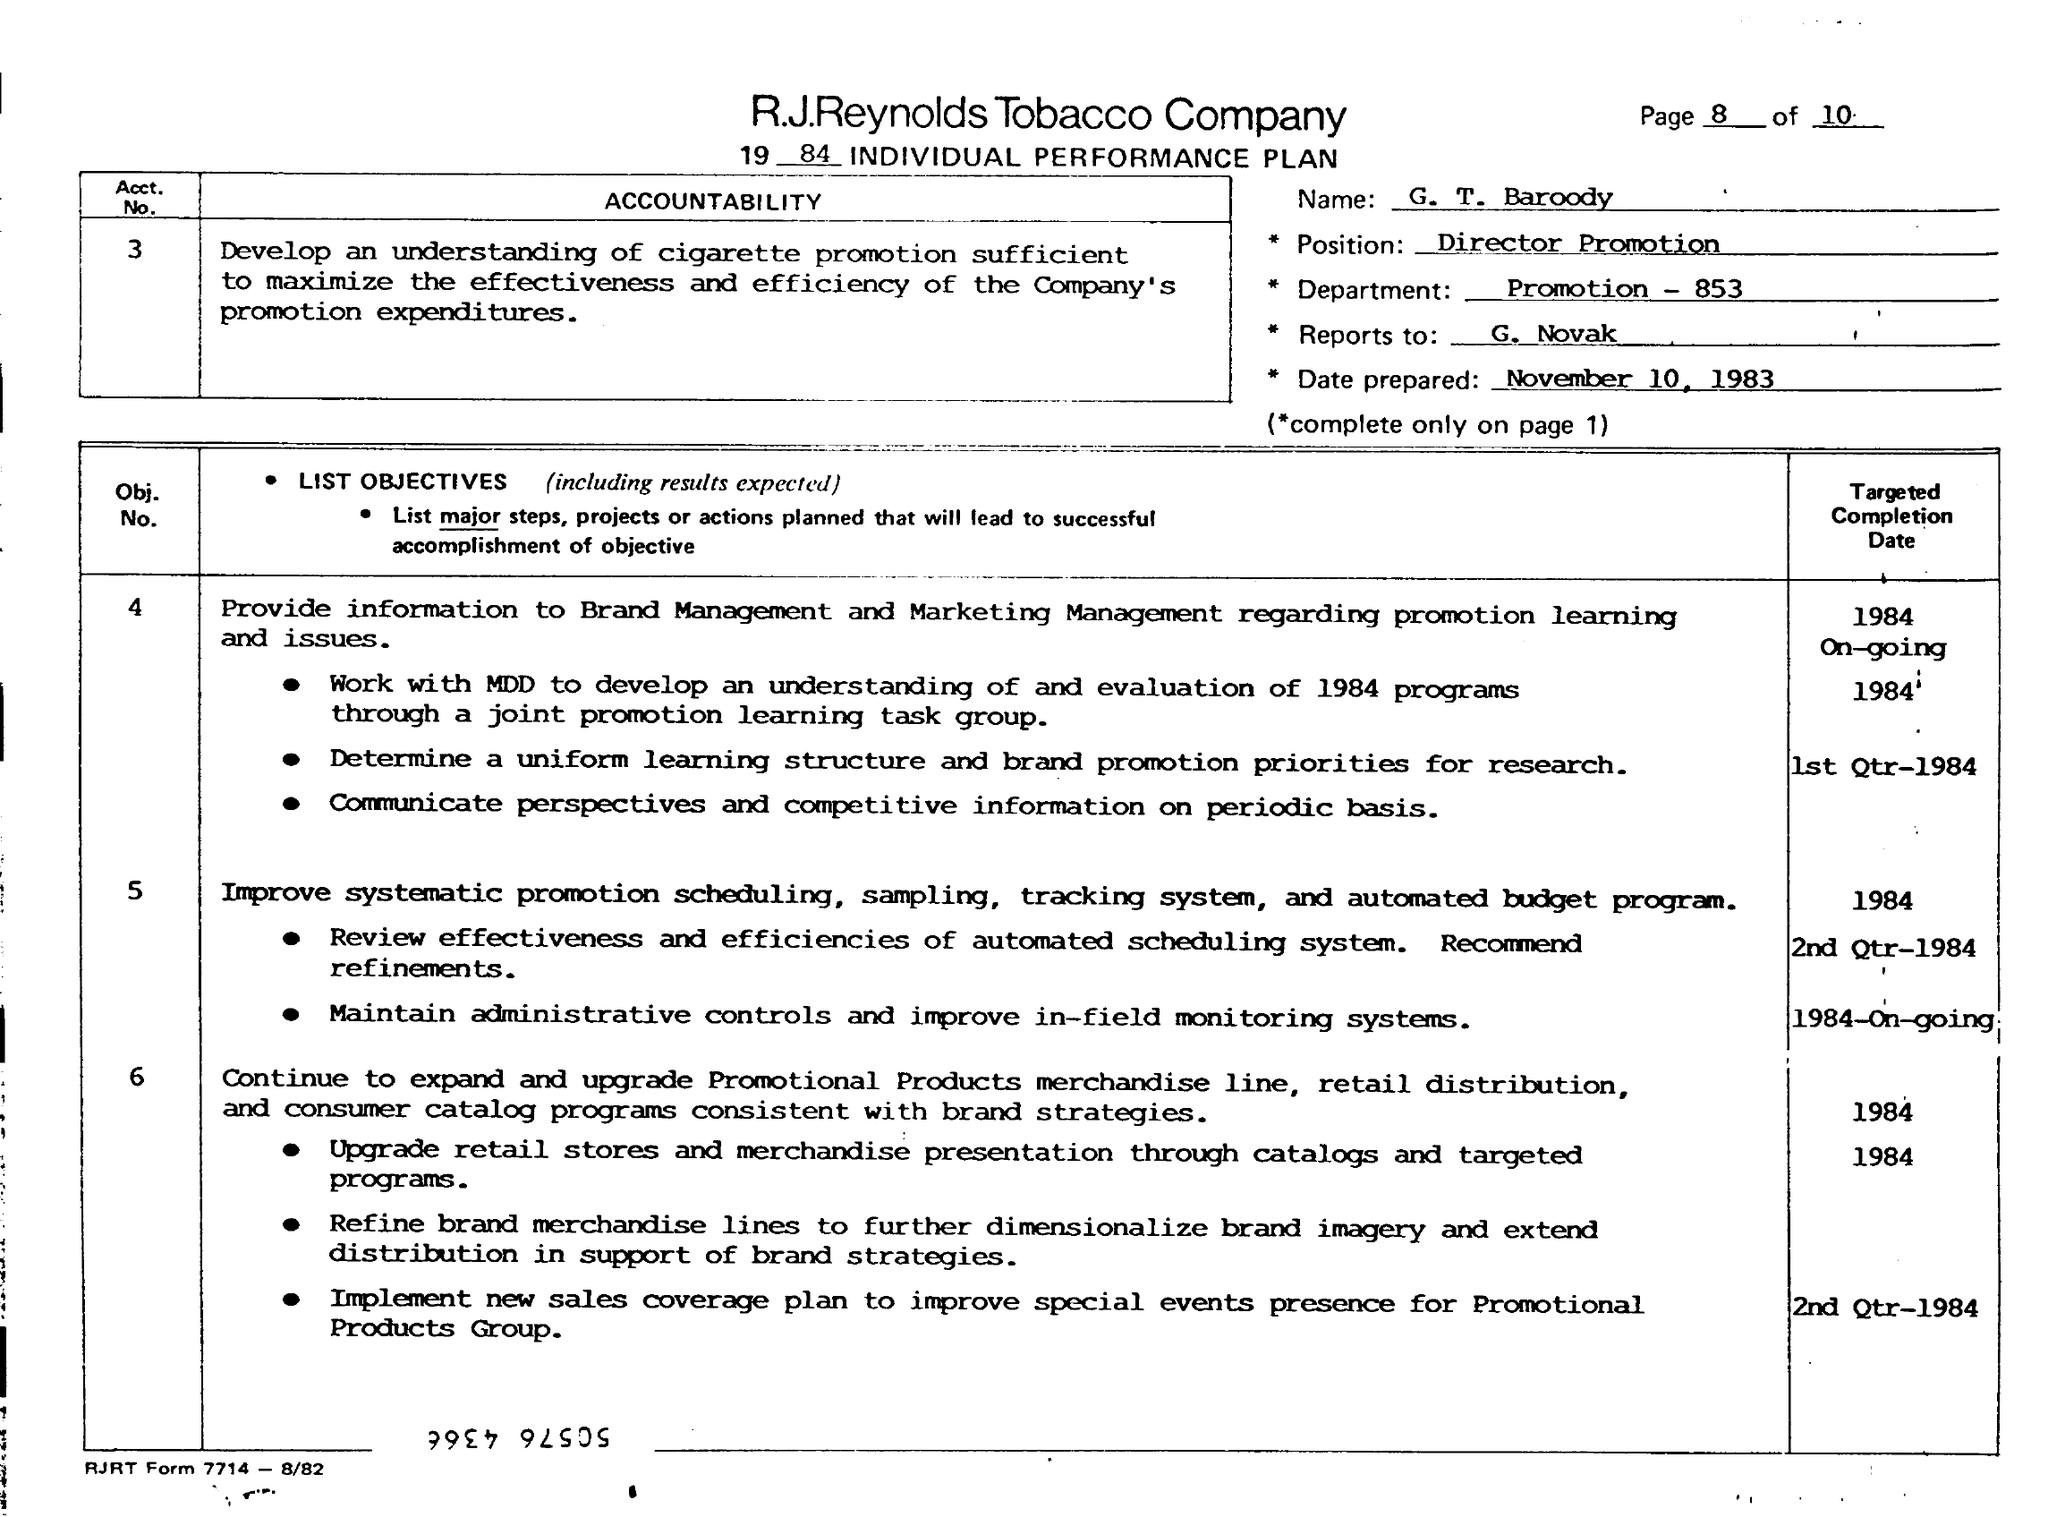Indicate a few pertinent items in this graphic. The basis for communicating perspectives and competitive information is periodic. 